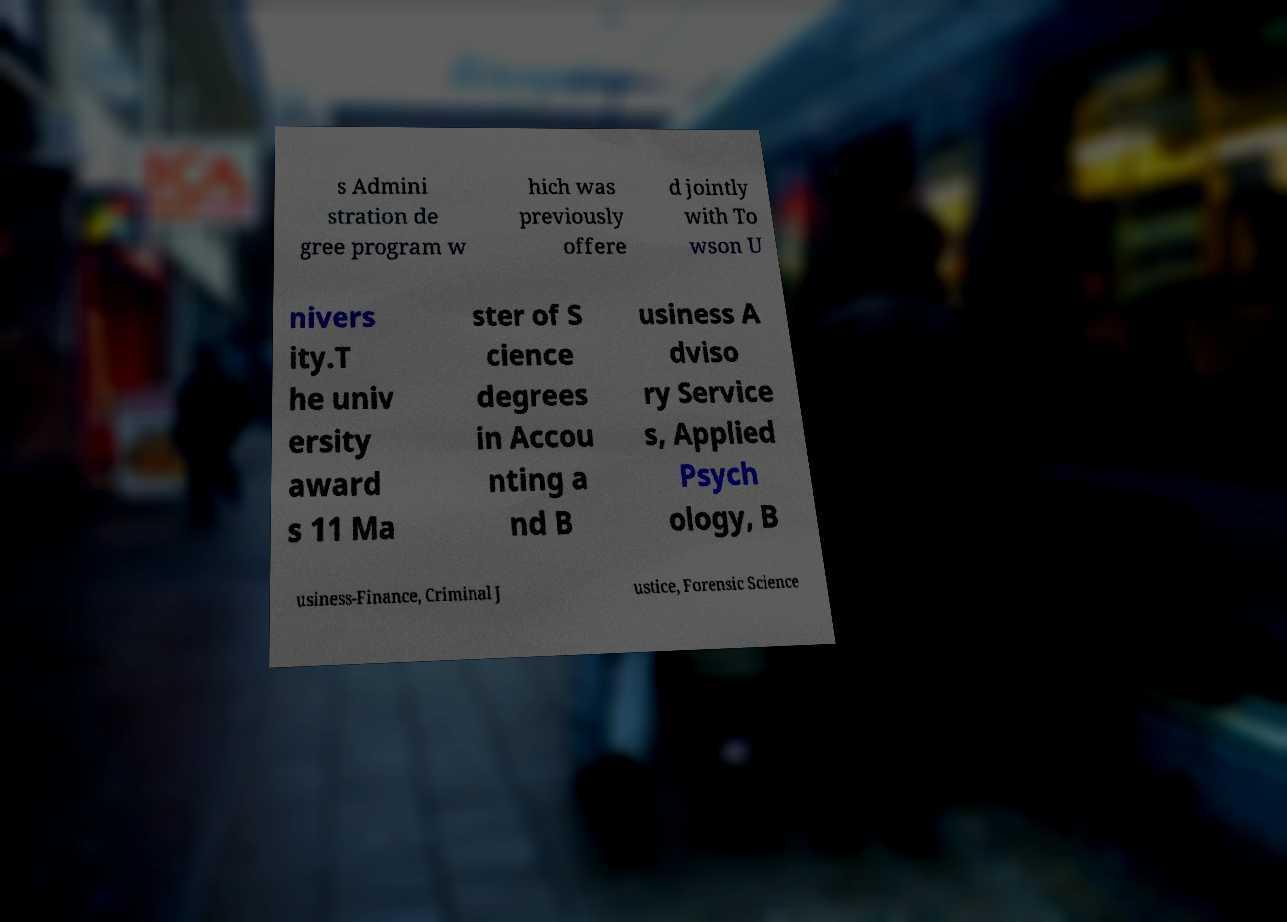What messages or text are displayed in this image? I need them in a readable, typed format. s Admini stration de gree program w hich was previously offere d jointly with To wson U nivers ity.T he univ ersity award s 11 Ma ster of S cience degrees in Accou nting a nd B usiness A dviso ry Service s, Applied Psych ology, B usiness-Finance, Criminal J ustice, Forensic Science 